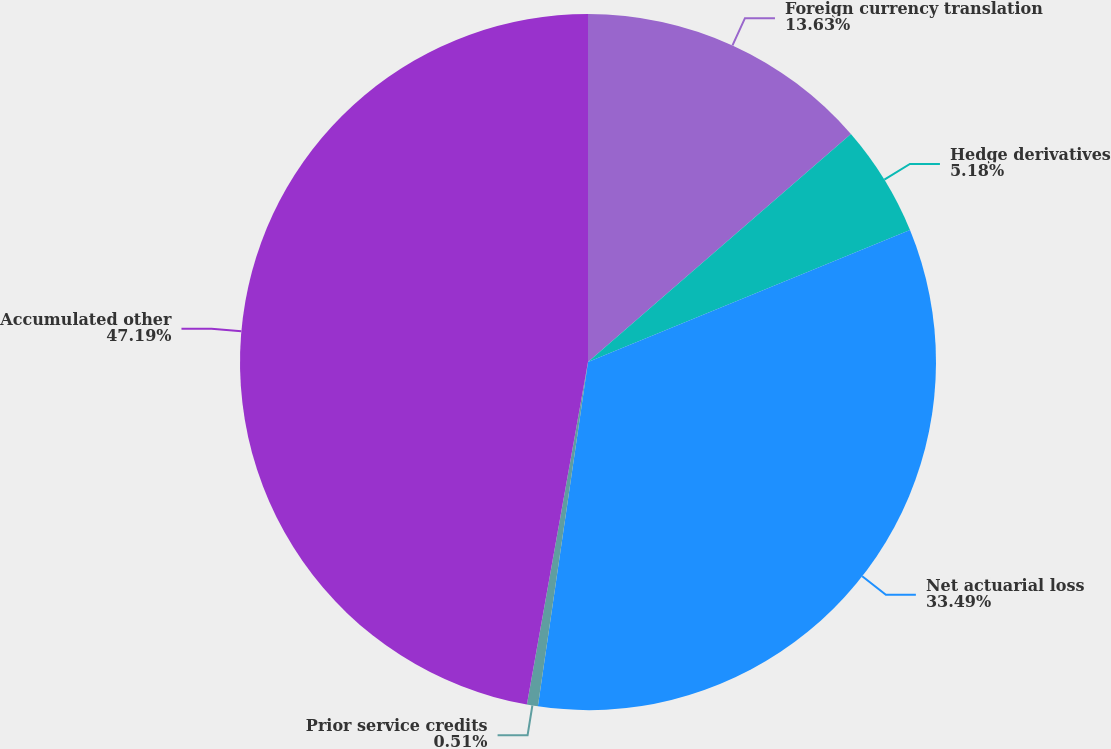Convert chart to OTSL. <chart><loc_0><loc_0><loc_500><loc_500><pie_chart><fcel>Foreign currency translation<fcel>Hedge derivatives<fcel>Net actuarial loss<fcel>Prior service credits<fcel>Accumulated other<nl><fcel>13.63%<fcel>5.18%<fcel>33.49%<fcel>0.51%<fcel>47.19%<nl></chart> 